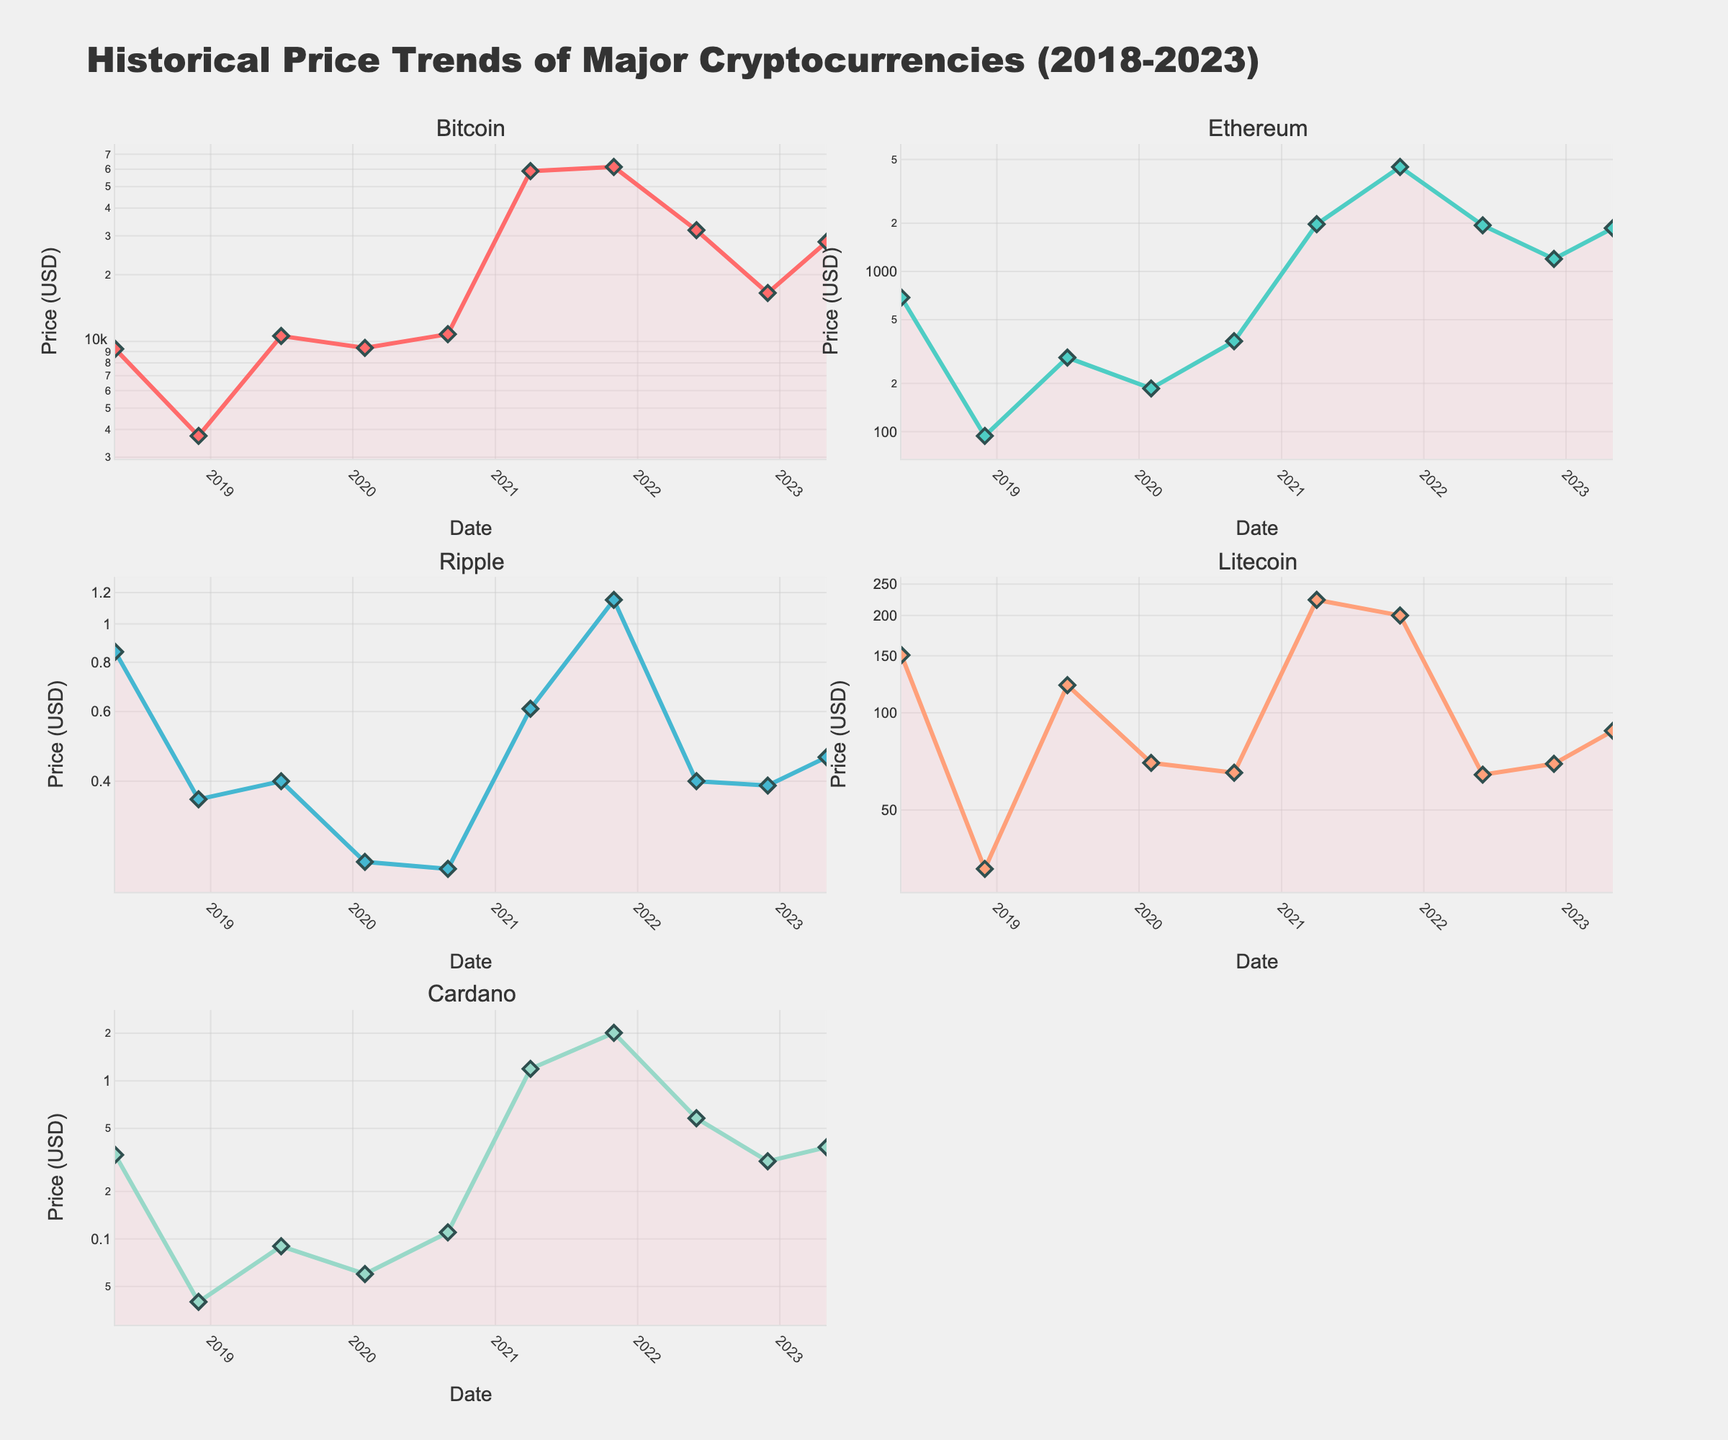What is the title of the figure? The title is located at the top center of the plot.
Answer: Historical Price Trends of Major Cryptocurrencies (2018-2023) How many cryptocurrencies are compared in the figure? Each subplot's title indicates one cryptocurrency, and there are six titles in total with 'Litecoin' being mentioned only once.
Answer: 5 Which cryptocurrency had the highest price at the peak? By inspecting the peak of the lines in each subplot, particularly in November 2021, we can see that Bitcoin's line is the highest.
Answer: Bitcoin Between Ethereum and Ripple, which cryptocurrency had a higher price on May 1, 2018? Comparing their respective values on May 1, 2018, Ethereum was $687.34 while Ripple was $0.85.
Answer: Ethereum What was the price of Cardano in November 2021? Looking at the Cardano subplot in November 2021, the point corresponds to $2.01.
Answer: $2.01 Which cryptocurrency experienced the most significant drop between April 2021 and June 2022? Analyzing the steepness of the drops, Bitcoin dropped from $58,771.25 to $31,792.31, which is more significant than the drops in other subplots.
Answer: Bitcoin What is the average price of Litecoin across all data points shown? Sum all Litecoin values (150.72 + 32.89 + 121.75 + 69.98 + 65.23 + 223.37 + 199.85 + 64.33 + 69.52 + 87.94), then divide by 10. (Sum = 1,085.58) / 10 = 108.56.
Answer: 108.56 Which two cryptocurrencies show an increase in price between June 2022 and December 2022? By comparing the lines from June to December 2022, both Ripple ($0.40 to $0.39) and Litecoin ($64.33 to $69.52) show stability or increase.
Answer: Litecoin and Cardano How did the price of Bitcoin change from May 2018 to December 2022? The plot for Bitcoin shows values of $9,244.32 in May 2018 and $16,547.50 in December 2022, indicating an increase.
Answer: Increased In which period did Ethereum see its highest price increase? Observing the Ethereum subplot, the steepest incline is from February 2020 ($185.94) to April 2021 ($1,971.32).
Answer: February 2020 to April 2021 